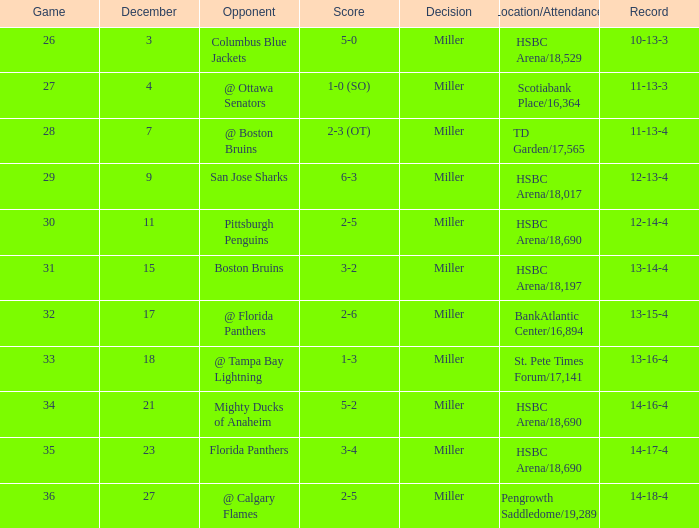Indicate the competitor with a record of 10-13- Columbus Blue Jackets. 